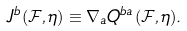Convert formula to latex. <formula><loc_0><loc_0><loc_500><loc_500>J ^ { b } ( \mathcal { F } , \eta ) \equiv \nabla _ { a } Q ^ { b a } ( \mathcal { F } , \eta ) .</formula> 